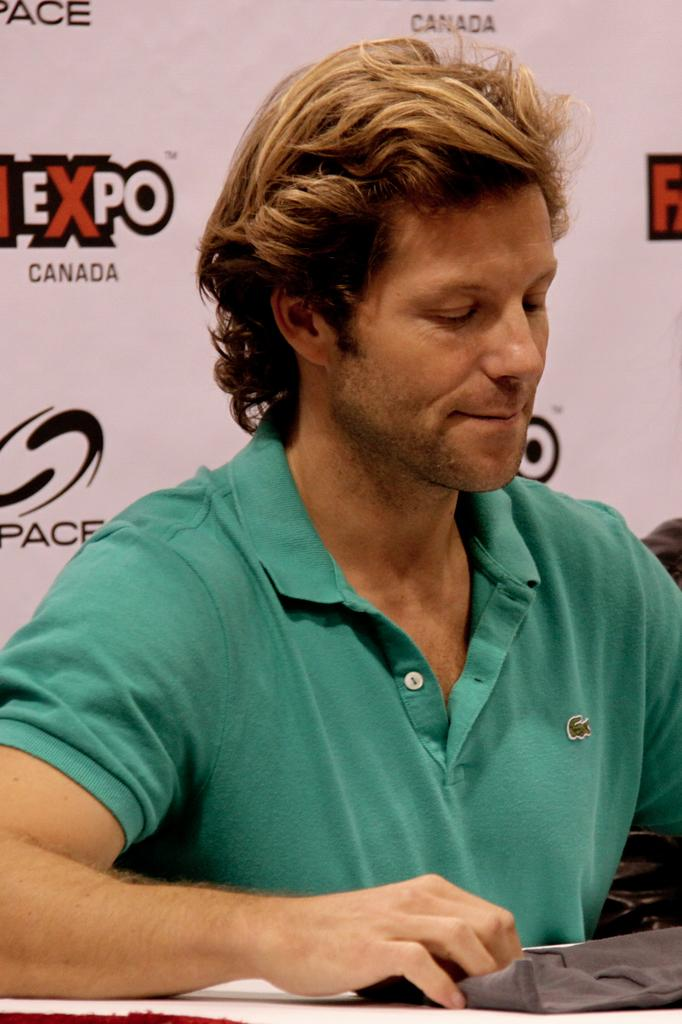What can be seen in the image? There is a person in the image. Can you describe the person's appearance? The person is wearing clothes. What else is visible in the image? There is text visible in the background of the image. What type of division can be seen in the image? There is no division present in the image; it features a person wearing clothes with text visible in the background. 